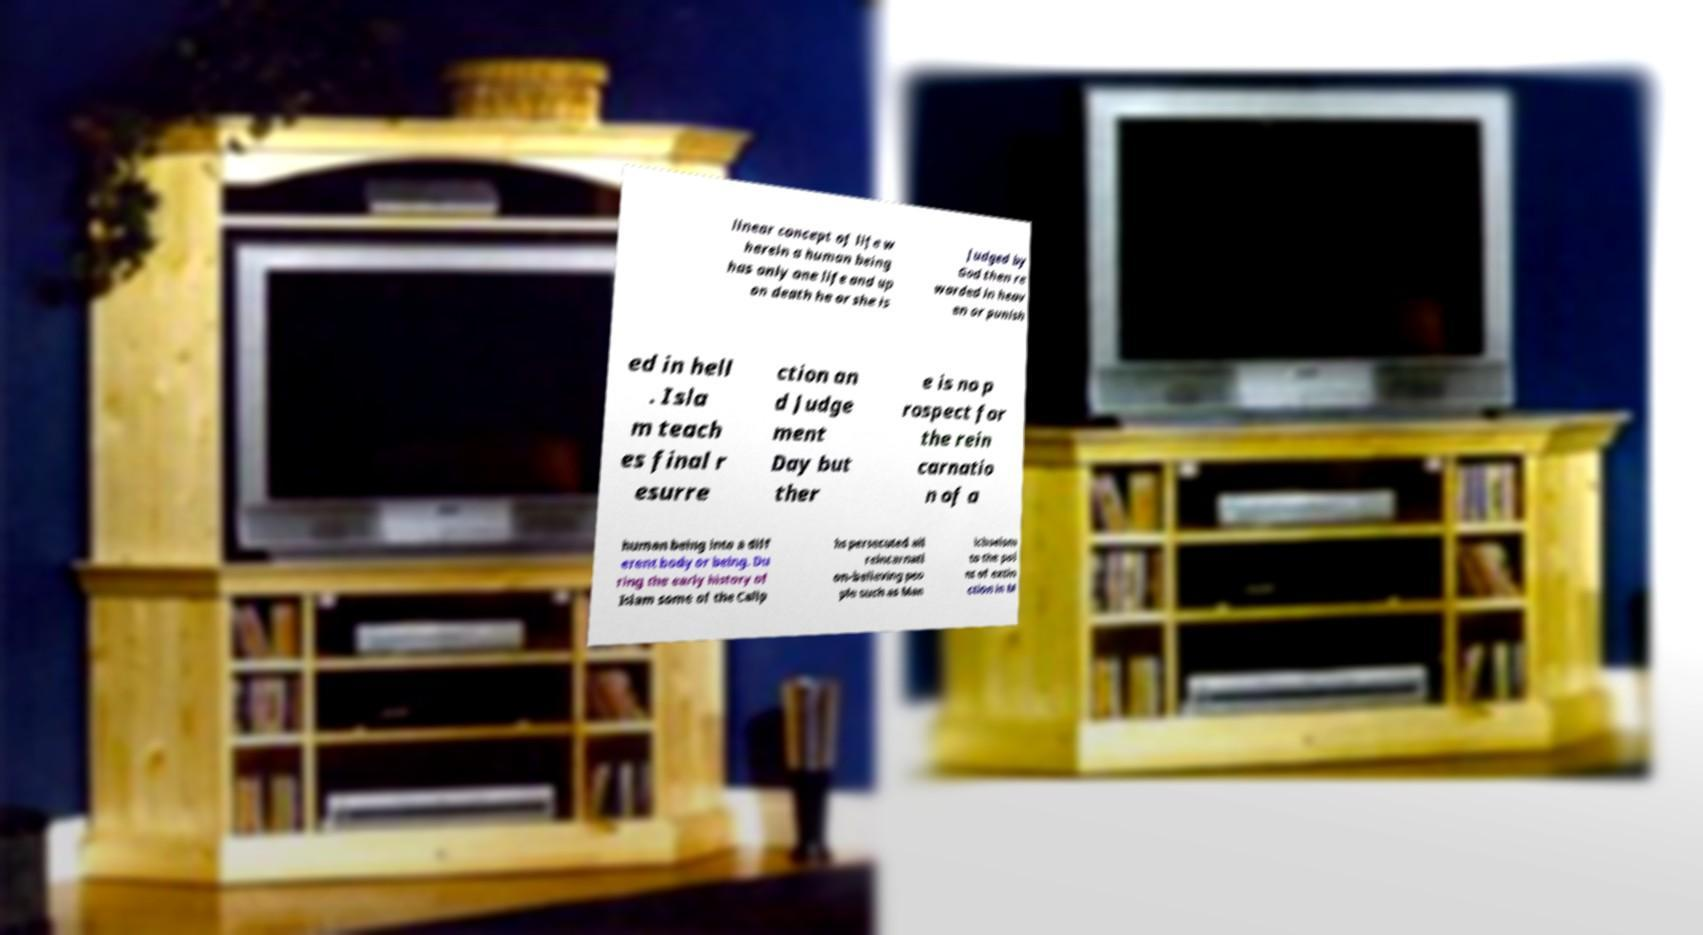What messages or text are displayed in this image? I need them in a readable, typed format. linear concept of life w herein a human being has only one life and up on death he or she is judged by God then re warded in heav en or punish ed in hell . Isla m teach es final r esurre ction an d Judge ment Day but ther e is no p rospect for the rein carnatio n of a human being into a diff erent body or being. Du ring the early history of Islam some of the Calip hs persecuted all reincarnati on-believing peo ple such as Man ichaeism to the poi nt of extin ction in M 